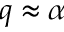<formula> <loc_0><loc_0><loc_500><loc_500>q \approx \alpha</formula> 